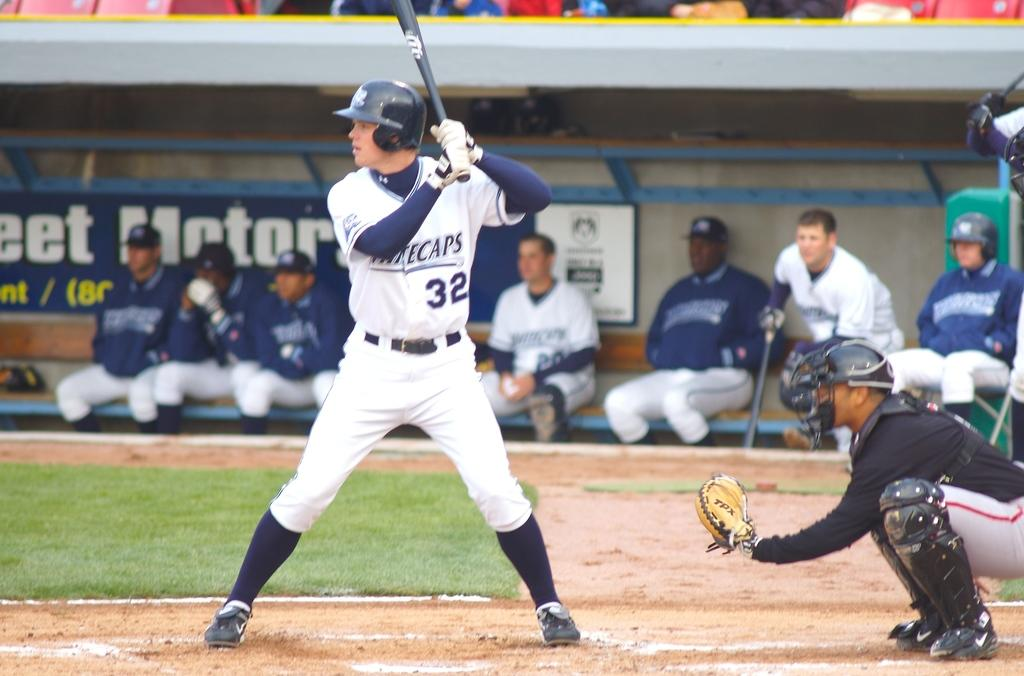<image>
Provide a brief description of the given image. The west Michigan Whitecaps are up to bat 